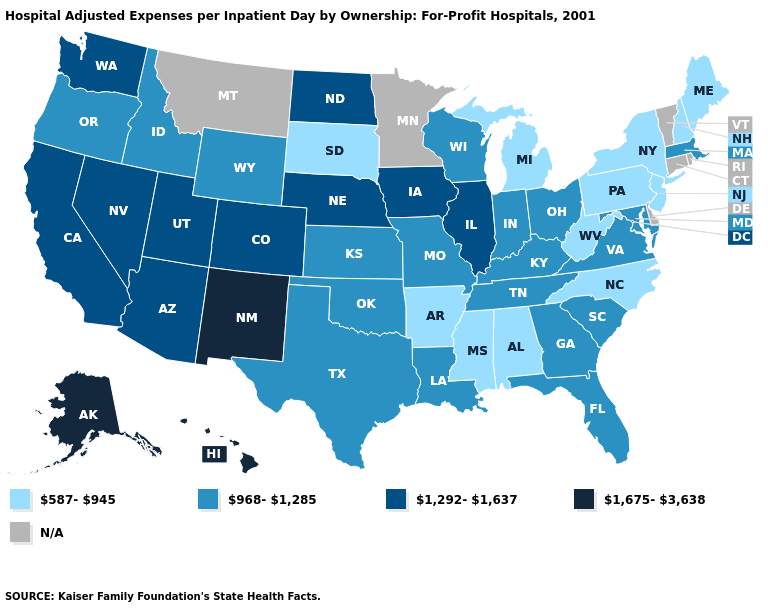What is the value of Delaware?
Quick response, please. N/A. What is the value of Pennsylvania?
Keep it brief. 587-945. What is the value of Alabama?
Give a very brief answer. 587-945. What is the value of Washington?
Answer briefly. 1,292-1,637. Does Michigan have the highest value in the MidWest?
Give a very brief answer. No. What is the value of Alaska?
Write a very short answer. 1,675-3,638. Name the states that have a value in the range 968-1,285?
Keep it brief. Florida, Georgia, Idaho, Indiana, Kansas, Kentucky, Louisiana, Maryland, Massachusetts, Missouri, Ohio, Oklahoma, Oregon, South Carolina, Tennessee, Texas, Virginia, Wisconsin, Wyoming. Is the legend a continuous bar?
Answer briefly. No. What is the value of Indiana?
Keep it brief. 968-1,285. What is the value of North Carolina?
Concise answer only. 587-945. What is the highest value in the USA?
Give a very brief answer. 1,675-3,638. Does Georgia have the lowest value in the USA?
Give a very brief answer. No. What is the value of Kentucky?
Keep it brief. 968-1,285. What is the value of Alaska?
Quick response, please. 1,675-3,638. Which states hav the highest value in the Northeast?
Write a very short answer. Massachusetts. 